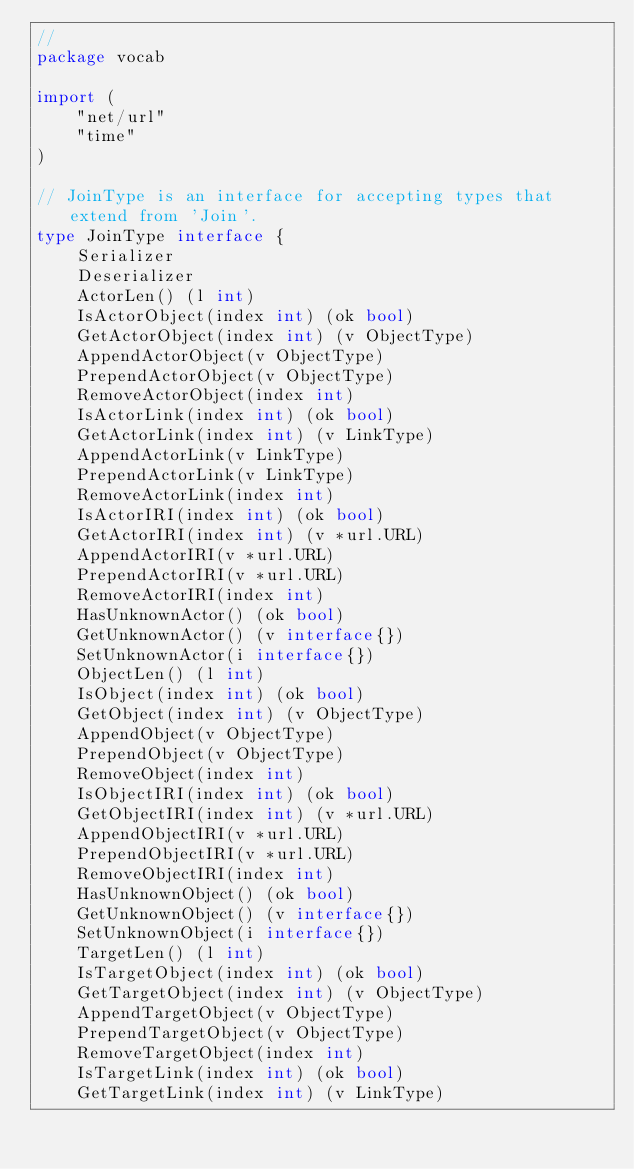Convert code to text. <code><loc_0><loc_0><loc_500><loc_500><_Go_>//
package vocab

import (
	"net/url"
	"time"
)

// JoinType is an interface for accepting types that extend from 'Join'.
type JoinType interface {
	Serializer
	Deserializer
	ActorLen() (l int)
	IsActorObject(index int) (ok bool)
	GetActorObject(index int) (v ObjectType)
	AppendActorObject(v ObjectType)
	PrependActorObject(v ObjectType)
	RemoveActorObject(index int)
	IsActorLink(index int) (ok bool)
	GetActorLink(index int) (v LinkType)
	AppendActorLink(v LinkType)
	PrependActorLink(v LinkType)
	RemoveActorLink(index int)
	IsActorIRI(index int) (ok bool)
	GetActorIRI(index int) (v *url.URL)
	AppendActorIRI(v *url.URL)
	PrependActorIRI(v *url.URL)
	RemoveActorIRI(index int)
	HasUnknownActor() (ok bool)
	GetUnknownActor() (v interface{})
	SetUnknownActor(i interface{})
	ObjectLen() (l int)
	IsObject(index int) (ok bool)
	GetObject(index int) (v ObjectType)
	AppendObject(v ObjectType)
	PrependObject(v ObjectType)
	RemoveObject(index int)
	IsObjectIRI(index int) (ok bool)
	GetObjectIRI(index int) (v *url.URL)
	AppendObjectIRI(v *url.URL)
	PrependObjectIRI(v *url.URL)
	RemoveObjectIRI(index int)
	HasUnknownObject() (ok bool)
	GetUnknownObject() (v interface{})
	SetUnknownObject(i interface{})
	TargetLen() (l int)
	IsTargetObject(index int) (ok bool)
	GetTargetObject(index int) (v ObjectType)
	AppendTargetObject(v ObjectType)
	PrependTargetObject(v ObjectType)
	RemoveTargetObject(index int)
	IsTargetLink(index int) (ok bool)
	GetTargetLink(index int) (v LinkType)</code> 